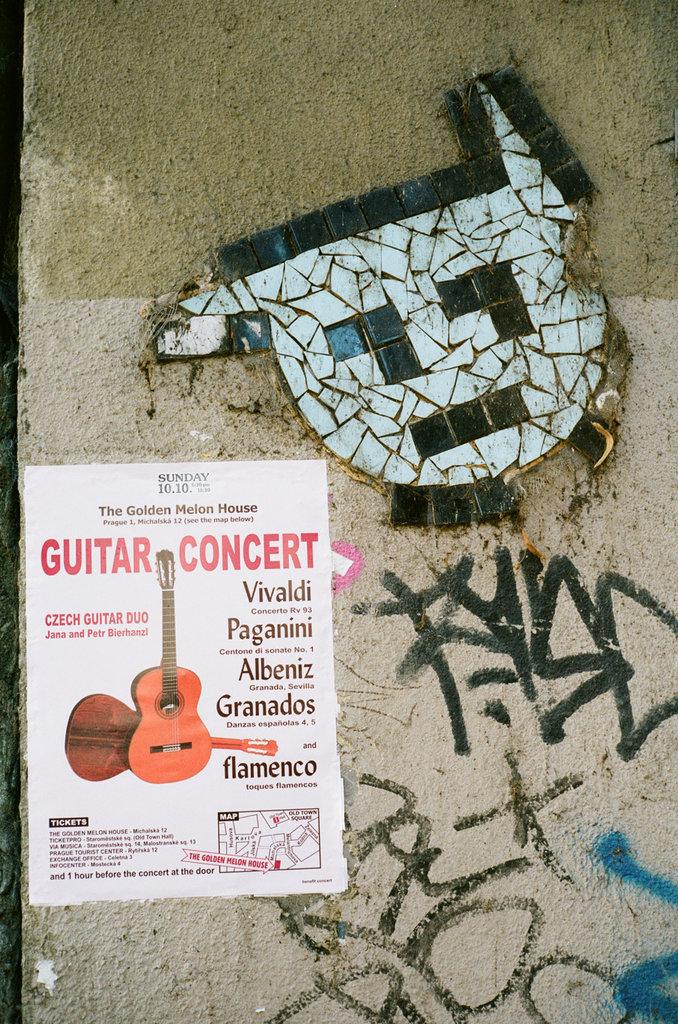What kind of concert is this?
Make the answer very short. Guitar. What day is the concert?
Give a very brief answer. Sunday. 